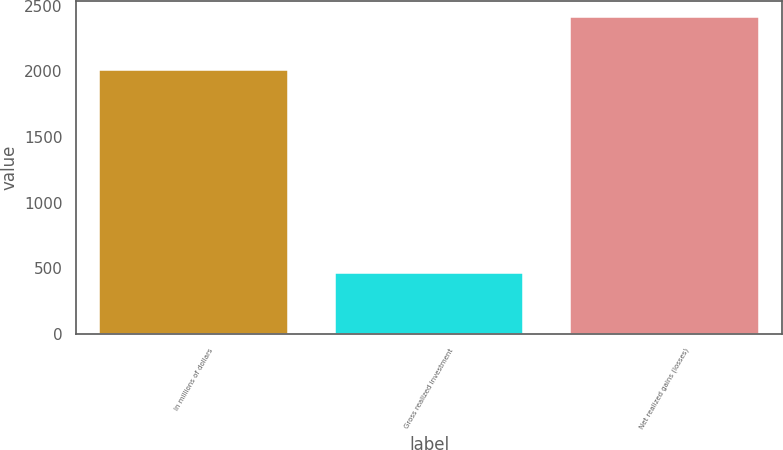Convert chart to OTSL. <chart><loc_0><loc_0><loc_500><loc_500><bar_chart><fcel>In millions of dollars<fcel>Gross realized investment<fcel>Net realized gains (losses)<nl><fcel>2010<fcel>462<fcel>2411<nl></chart> 